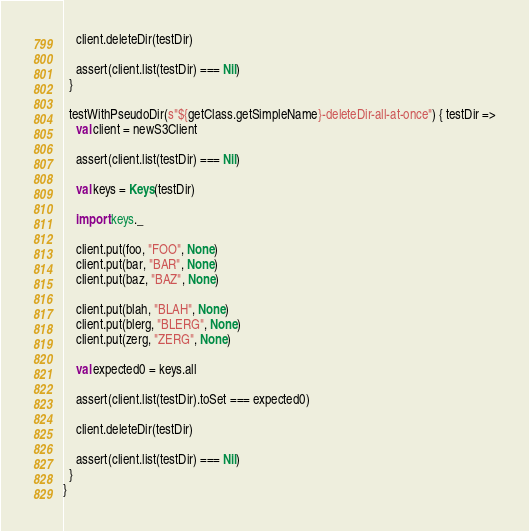<code> <loc_0><loc_0><loc_500><loc_500><_Scala_>    client.deleteDir(testDir)
    
    assert(client.list(testDir) === Nil)
  }
  
  testWithPseudoDir(s"${getClass.getSimpleName}-deleteDir-all-at-once") { testDir =>
    val client = newS3Client
      
    assert(client.list(testDir) === Nil)
    
    val keys = Keys(testDir)
    
    import keys._
    
    client.put(foo, "FOO", None)
    client.put(bar, "BAR", None)
    client.put(baz, "BAZ", None)
    
    client.put(blah, "BLAH", None)
    client.put(blerg, "BLERG", None)
    client.put(zerg, "ZERG", None)
    
    val expected0 = keys.all
        
    assert(client.list(testDir).toSet === expected0)
    
    client.deleteDir(testDir)

    assert(client.list(testDir) === Nil)
  }
}
</code> 